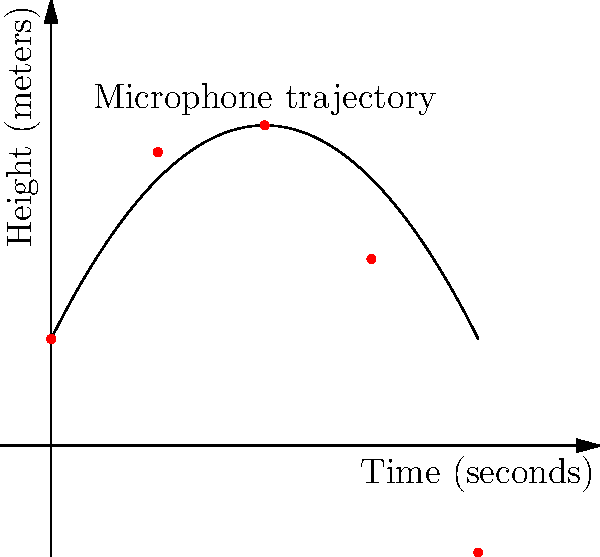During an Elbow concert, the lead singer throws his microphone in the air. The trajectory of the microphone can be modeled by the quadratic equation $h(t) = -0.1t^2 + 2t + 5$, where $h$ is the height in meters and $t$ is the time in seconds. At what time does the microphone reach its maximum height? To find the time when the microphone reaches its maximum height, we need to follow these steps:

1) The quadratic equation is in the form $h(t) = -0.1t^2 + 2t + 5$

2) For a quadratic equation in the form $f(x) = ax^2 + bx + c$, the x-coordinate of the vertex (which represents the maximum or minimum point) is given by the formula: $x = -\frac{b}{2a}$

3) In our case, $a = -0.1$ and $b = 2$

4) Substituting these values into the formula:

   $t = -\frac{2}{2(-0.1)} = -\frac{2}{-0.2} = \frac{2}{0.2} = 10$

5) Therefore, the microphone reaches its maximum height at $t = 10$ seconds.

We can verify this by looking at the graph, where we can see the peak of the parabola occurs at $t = 10$.
Answer: 10 seconds 